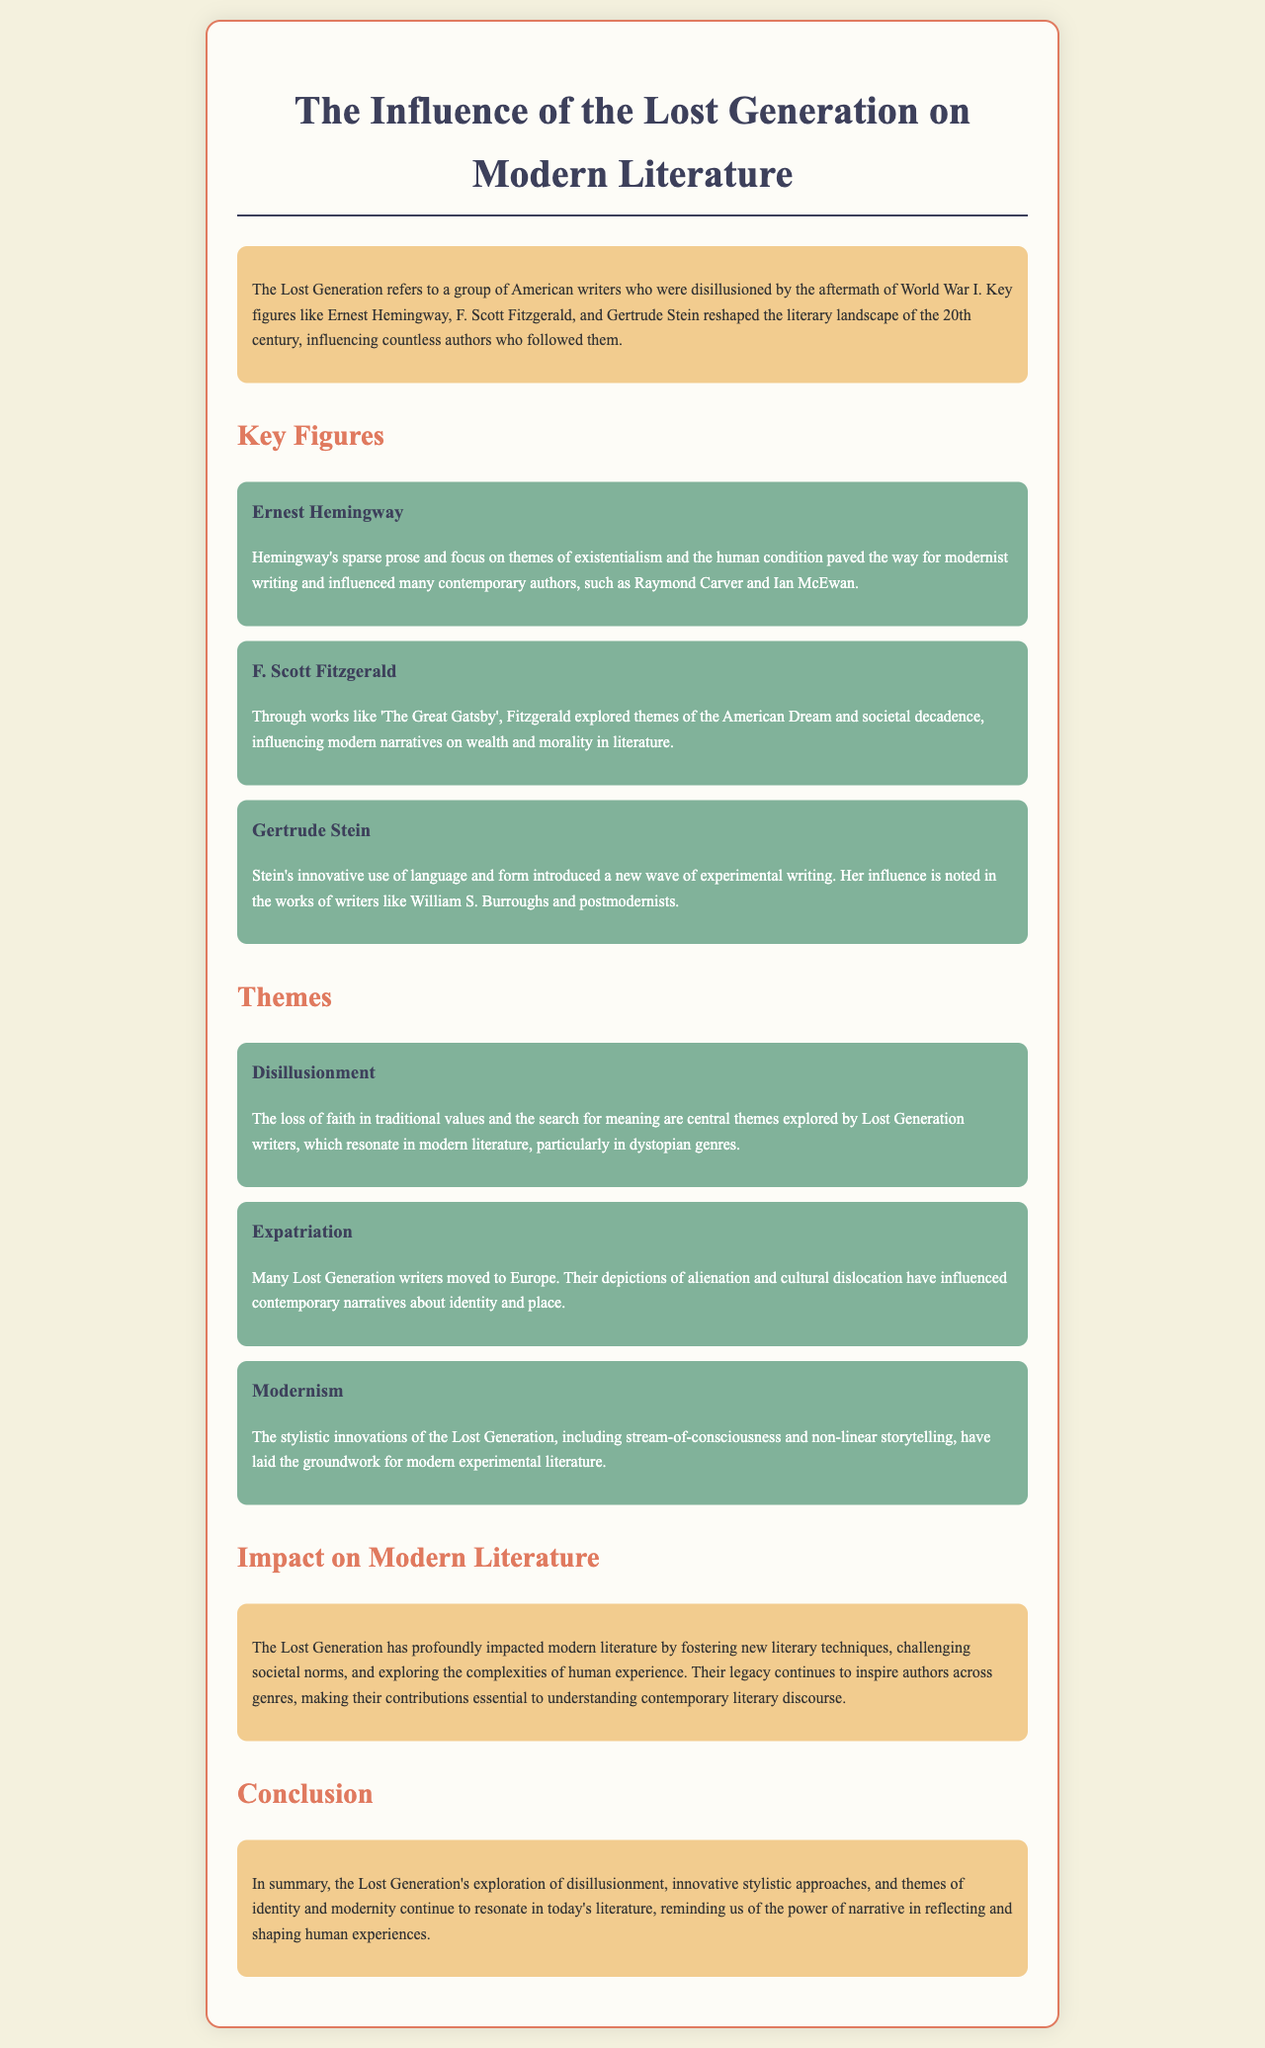What does the term "Lost Generation" refer to? The term refers to a group of American writers disillusioned by the aftermath of World War I.
Answer: A group of American writers disillusioned by the aftermath of World War I Who is a key figure known for slender prose? This refers to a key figure whose writing style is characterized by sparse prose and existential themes.
Answer: Ernest Hemingway What literary work is associated with F. Scott Fitzgerald? The question asks for a key literary work mentioned in the document that he explored themes of the American Dream through.
Answer: The Great Gatsby What is a central theme explored by Lost Generation writers? This question seeks to identify a key thematic element that resonates in modern literature as stated in the document.
Answer: Disillusionment What literary technique did the Lost Generation notably introduce? The inquiry looks for a significant innovation from the Lost Generation that impacted modern literary styles.
Answer: Stream-of-consciousness What impact did the Lost Generation have on contemporary authors? This question wants to know the general effect of the Lost Generation’s contributions on modern writers as described in the document.
Answer: Inspired authors across genres What does the conclusion of the brochure emphasize? The question is asking what key point is highlighted in the conclusion regarding the Lost Generation's ongoing influence.
Answer: The power of narrative in reflecting and shaping human experiences 